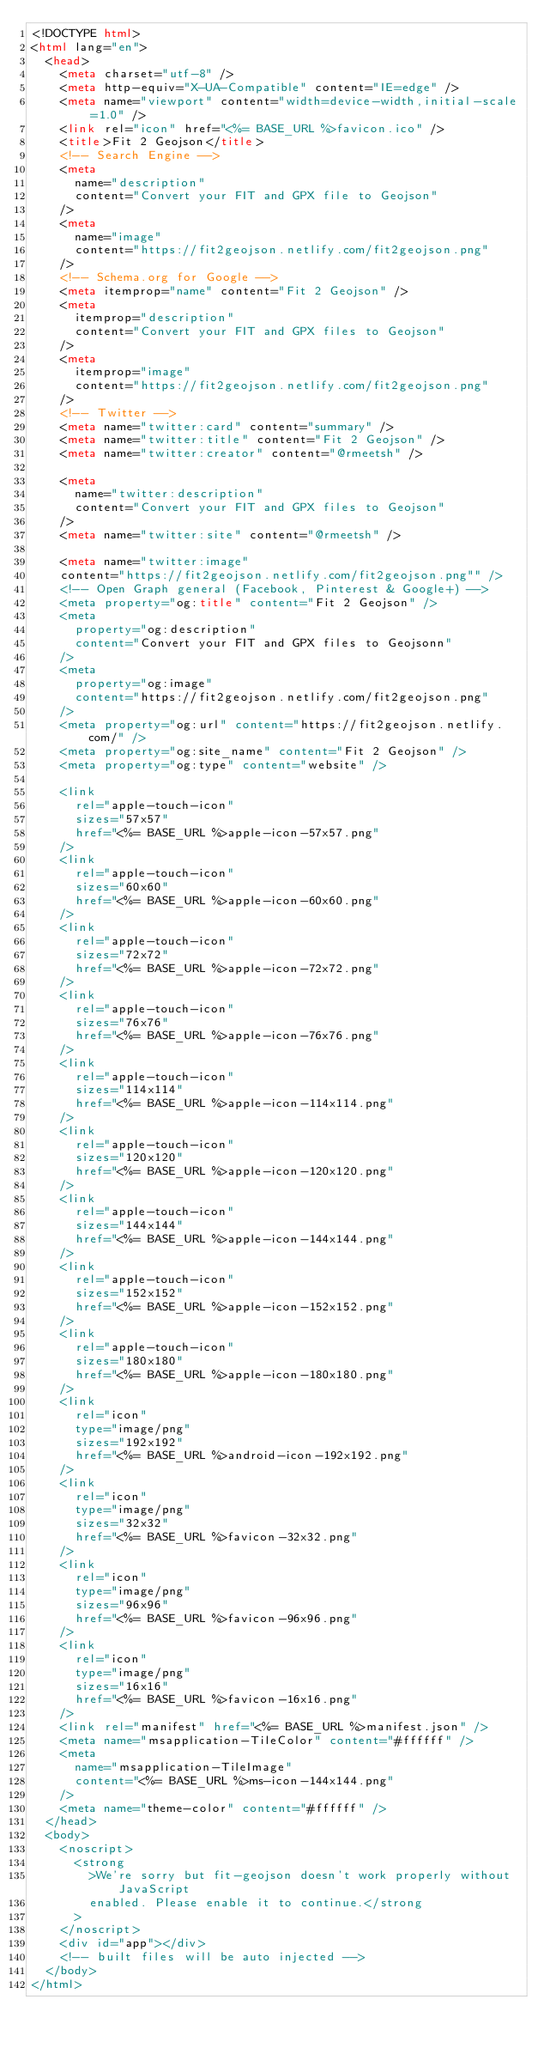<code> <loc_0><loc_0><loc_500><loc_500><_HTML_><!DOCTYPE html>
<html lang="en">
  <head>
    <meta charset="utf-8" />
    <meta http-equiv="X-UA-Compatible" content="IE=edge" />
    <meta name="viewport" content="width=device-width,initial-scale=1.0" />
    <link rel="icon" href="<%= BASE_URL %>favicon.ico" />
    <title>Fit 2 Geojson</title>
    <!-- Search Engine -->
    <meta
      name="description"
      content="Convert your FIT and GPX file to Geojson"
    />
    <meta
      name="image"
      content="https://fit2geojson.netlify.com/fit2geojson.png"
    />
    <!-- Schema.org for Google -->
    <meta itemprop="name" content="Fit 2 Geojson" />
    <meta
      itemprop="description"
      content="Convert your FIT and GPX files to Geojson"
    />
    <meta
      itemprop="image"
      content="https://fit2geojson.netlify.com/fit2geojson.png"
    />
    <!-- Twitter -->
    <meta name="twitter:card" content="summary" />
    <meta name="twitter:title" content="Fit 2 Geojson" />
    <meta name="twitter:creator" content="@rmeetsh" />

    <meta
      name="twitter:description"
      content="Convert your FIT and GPX files to Geojson"
    />
    <meta name="twitter:site" content="@rmeetsh" />

    <meta name="twitter:image"
    content="https://fit2geojson.netlify.com/fit2geojson.png"" />
    <!-- Open Graph general (Facebook, Pinterest & Google+) -->
    <meta property="og:title" content="Fit 2 Geojson" />
    <meta
      property="og:description"
      content="Convert your FIT and GPX files to Geojsonn"
    />
    <meta
      property="og:image"
      content="https://fit2geojson.netlify.com/fit2geojson.png"
    />
    <meta property="og:url" content="https://fit2geojson.netlify.com/" />
    <meta property="og:site_name" content="Fit 2 Geojson" />
    <meta property="og:type" content="website" />

    <link
      rel="apple-touch-icon"
      sizes="57x57"
      href="<%= BASE_URL %>apple-icon-57x57.png"
    />
    <link
      rel="apple-touch-icon"
      sizes="60x60"
      href="<%= BASE_URL %>apple-icon-60x60.png"
    />
    <link
      rel="apple-touch-icon"
      sizes="72x72"
      href="<%= BASE_URL %>apple-icon-72x72.png"
    />
    <link
      rel="apple-touch-icon"
      sizes="76x76"
      href="<%= BASE_URL %>apple-icon-76x76.png"
    />
    <link
      rel="apple-touch-icon"
      sizes="114x114"
      href="<%= BASE_URL %>apple-icon-114x114.png"
    />
    <link
      rel="apple-touch-icon"
      sizes="120x120"
      href="<%= BASE_URL %>apple-icon-120x120.png"
    />
    <link
      rel="apple-touch-icon"
      sizes="144x144"
      href="<%= BASE_URL %>apple-icon-144x144.png"
    />
    <link
      rel="apple-touch-icon"
      sizes="152x152"
      href="<%= BASE_URL %>apple-icon-152x152.png"
    />
    <link
      rel="apple-touch-icon"
      sizes="180x180"
      href="<%= BASE_URL %>apple-icon-180x180.png"
    />
    <link
      rel="icon"
      type="image/png"
      sizes="192x192"
      href="<%= BASE_URL %>android-icon-192x192.png"
    />
    <link
      rel="icon"
      type="image/png"
      sizes="32x32"
      href="<%= BASE_URL %>favicon-32x32.png"
    />
    <link
      rel="icon"
      type="image/png"
      sizes="96x96"
      href="<%= BASE_URL %>favicon-96x96.png"
    />
    <link
      rel="icon"
      type="image/png"
      sizes="16x16"
      href="<%= BASE_URL %>favicon-16x16.png"
    />
    <link rel="manifest" href="<%= BASE_URL %>manifest.json" />
    <meta name="msapplication-TileColor" content="#ffffff" />
    <meta
      name="msapplication-TileImage"
      content="<%= BASE_URL %>ms-icon-144x144.png"
    />
    <meta name="theme-color" content="#ffffff" />
  </head>
  <body>
    <noscript>
      <strong
        >We're sorry but fit-geojson doesn't work properly without JavaScript
        enabled. Please enable it to continue.</strong
      >
    </noscript>
    <div id="app"></div>
    <!-- built files will be auto injected -->
  </body>
</html>
</code> 